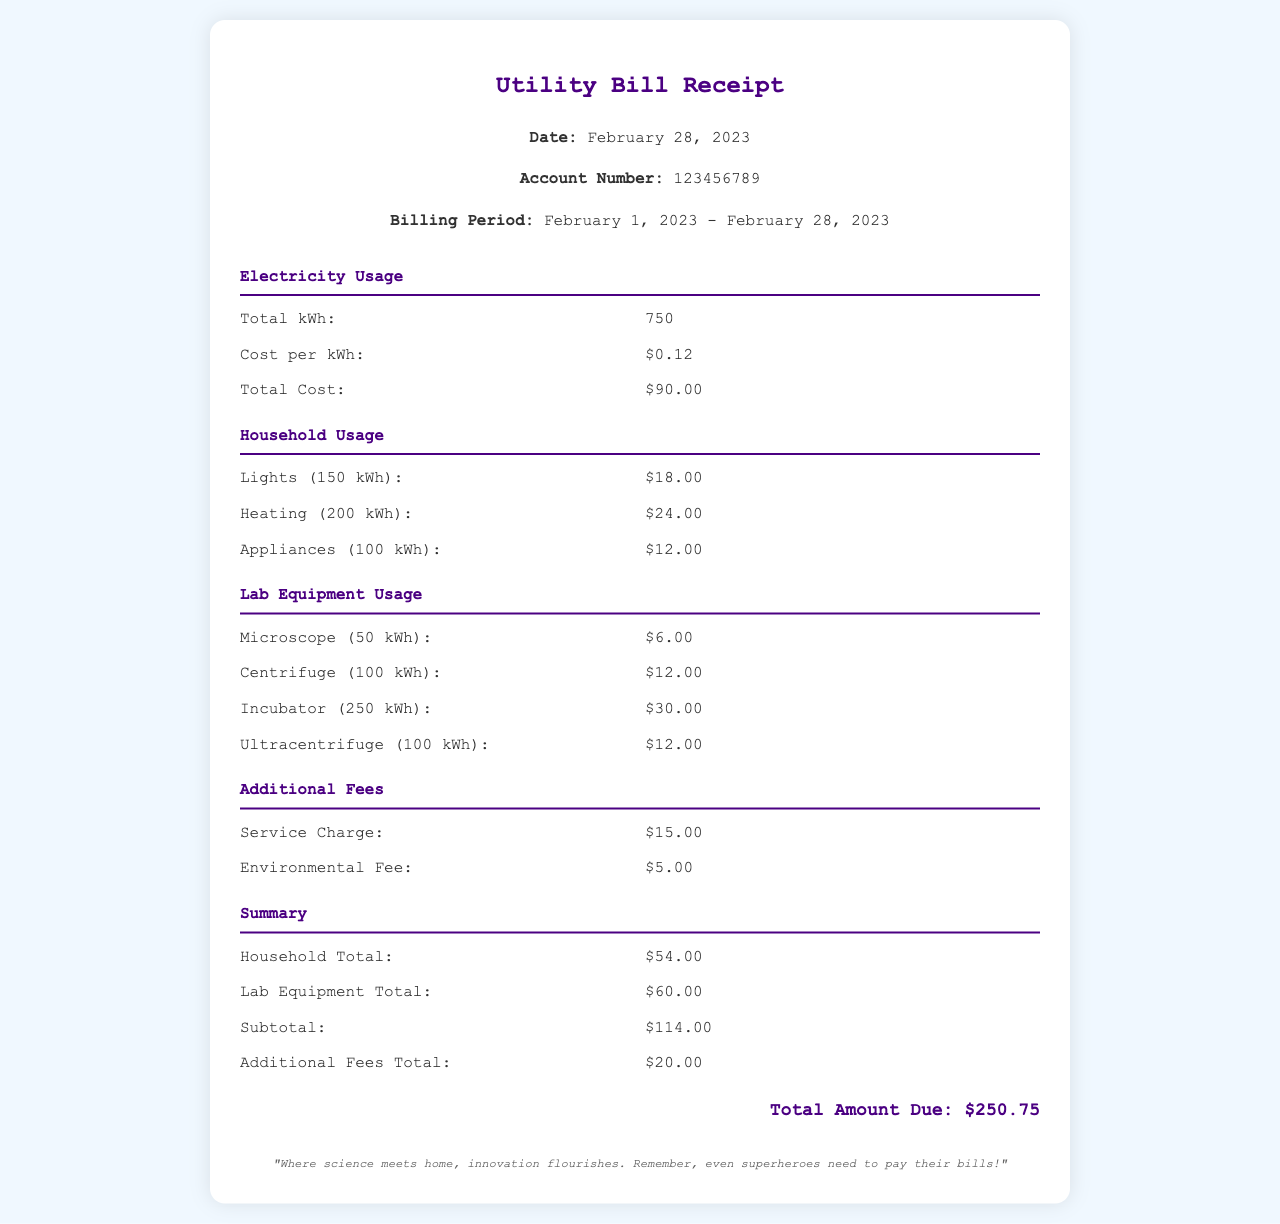What is the total kWh used in February 2023? The total kWh is stated in the electricity usage section as 750 kWh.
Answer: 750 kWh What is the cost per kWh? The cost per kWh is listed in the electricity usage section, which is $0.12.
Answer: $0.12 What was the total cost for household electricity usage? The household total is given as $54.00 in the summary section.
Answer: $54.00 How much electricity did the incubator use? The incubator usage is specified as 250 kWh in the lab equipment section.
Answer: 250 kWh What are the additional fees listed on the receipt? The additional fees include a service charge of $15.00 and an environmental fee of $5.00.
Answer: Service Charge: $15.00; Environmental Fee: $5.00 What is the total amount due? The total amount due is explicitly mentioned as $250.75 at the bottom of the document.
Answer: $250.75 How much did the centrifuge consume in kWh? The centrifuge is stated to have consumed 100 kWh in the lab equipment section.
Answer: 100 kWh What is the billing period for this utility bill? The billing period is specified as February 1, 2023 - February 28, 2023.
Answer: February 1, 2023 - February 28, 2023 What is the total electricity usage for lab equipment? The total for lab equipment is summed up to $60.00 in the summary section.
Answer: $60.00 